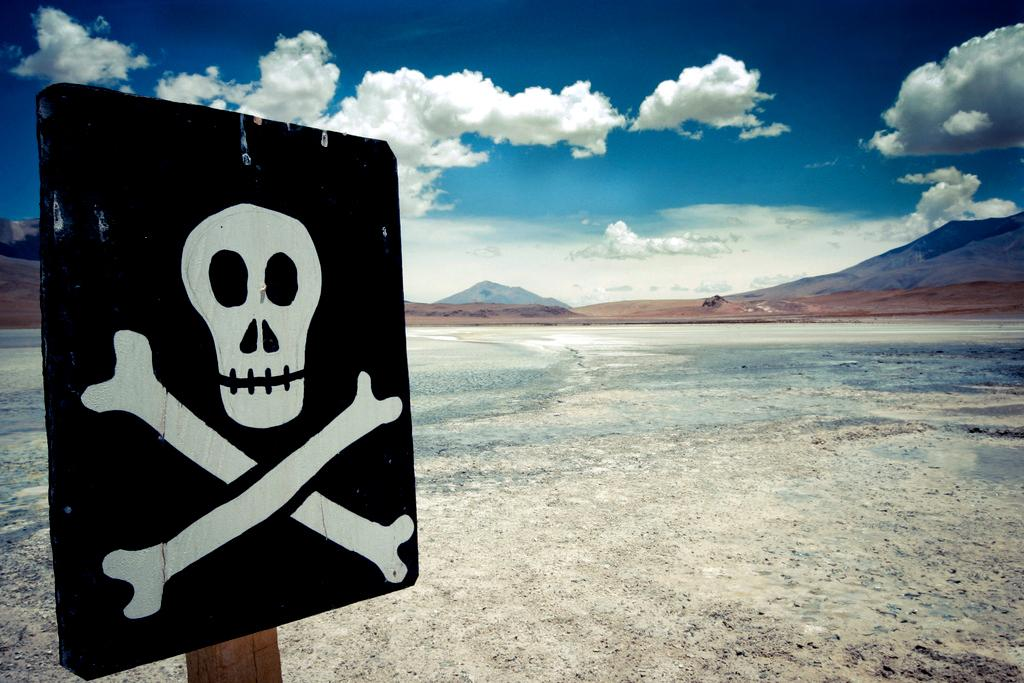What is located on the left side of the image? There is a sign board in the left side of the image. What can be seen in the background of the image? There is a hill in the background of the image. How would you describe the sky in the image? The sky is cloudy. How many nuts are scattered on the hill in the image? There are no nuts visible in the image; the hill is in the background and does not have any nuts present. 